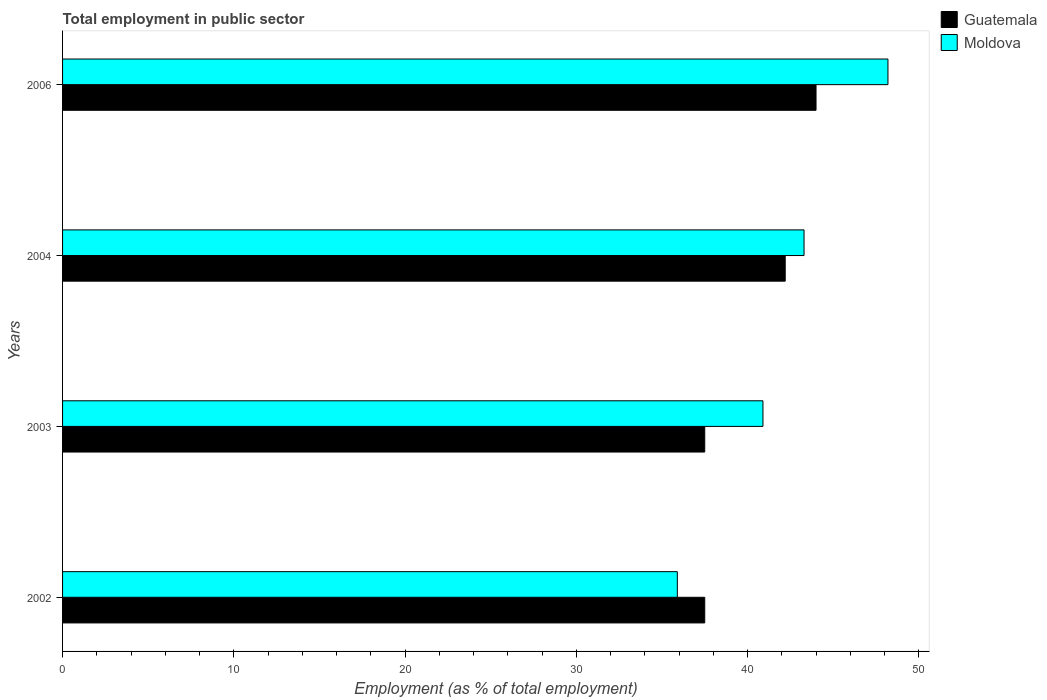How many different coloured bars are there?
Make the answer very short. 2. Are the number of bars per tick equal to the number of legend labels?
Your response must be concise. Yes. How many bars are there on the 4th tick from the top?
Offer a very short reply. 2. How many bars are there on the 4th tick from the bottom?
Your answer should be very brief. 2. What is the label of the 2nd group of bars from the top?
Offer a terse response. 2004. In how many cases, is the number of bars for a given year not equal to the number of legend labels?
Offer a very short reply. 0. What is the employment in public sector in Guatemala in 2002?
Provide a succinct answer. 37.5. Across all years, what is the maximum employment in public sector in Moldova?
Offer a terse response. 48.2. Across all years, what is the minimum employment in public sector in Moldova?
Give a very brief answer. 35.9. In which year was the employment in public sector in Guatemala maximum?
Ensure brevity in your answer.  2006. What is the total employment in public sector in Moldova in the graph?
Provide a short and direct response. 168.3. What is the difference between the employment in public sector in Moldova in 2004 and the employment in public sector in Guatemala in 2002?
Make the answer very short. 5.8. What is the average employment in public sector in Guatemala per year?
Keep it short and to the point. 40.3. In the year 2003, what is the difference between the employment in public sector in Moldova and employment in public sector in Guatemala?
Ensure brevity in your answer.  3.4. What is the ratio of the employment in public sector in Guatemala in 2003 to that in 2004?
Provide a short and direct response. 0.89. What is the difference between the highest and the second highest employment in public sector in Guatemala?
Offer a terse response. 1.8. What does the 2nd bar from the top in 2004 represents?
Offer a very short reply. Guatemala. What does the 1st bar from the bottom in 2004 represents?
Give a very brief answer. Guatemala. How many bars are there?
Make the answer very short. 8. How many years are there in the graph?
Offer a very short reply. 4. Are the values on the major ticks of X-axis written in scientific E-notation?
Keep it short and to the point. No. Does the graph contain grids?
Provide a succinct answer. No. Where does the legend appear in the graph?
Keep it short and to the point. Top right. How are the legend labels stacked?
Make the answer very short. Vertical. What is the title of the graph?
Ensure brevity in your answer.  Total employment in public sector. What is the label or title of the X-axis?
Keep it short and to the point. Employment (as % of total employment). What is the label or title of the Y-axis?
Offer a terse response. Years. What is the Employment (as % of total employment) of Guatemala in 2002?
Give a very brief answer. 37.5. What is the Employment (as % of total employment) of Moldova in 2002?
Keep it short and to the point. 35.9. What is the Employment (as % of total employment) in Guatemala in 2003?
Ensure brevity in your answer.  37.5. What is the Employment (as % of total employment) of Moldova in 2003?
Keep it short and to the point. 40.9. What is the Employment (as % of total employment) in Guatemala in 2004?
Your answer should be compact. 42.2. What is the Employment (as % of total employment) in Moldova in 2004?
Keep it short and to the point. 43.3. What is the Employment (as % of total employment) in Guatemala in 2006?
Provide a short and direct response. 44. What is the Employment (as % of total employment) in Moldova in 2006?
Your response must be concise. 48.2. Across all years, what is the maximum Employment (as % of total employment) in Guatemala?
Make the answer very short. 44. Across all years, what is the maximum Employment (as % of total employment) of Moldova?
Ensure brevity in your answer.  48.2. Across all years, what is the minimum Employment (as % of total employment) of Guatemala?
Make the answer very short. 37.5. Across all years, what is the minimum Employment (as % of total employment) of Moldova?
Provide a succinct answer. 35.9. What is the total Employment (as % of total employment) of Guatemala in the graph?
Your answer should be very brief. 161.2. What is the total Employment (as % of total employment) in Moldova in the graph?
Offer a terse response. 168.3. What is the difference between the Employment (as % of total employment) of Guatemala in 2002 and that in 2003?
Ensure brevity in your answer.  0. What is the difference between the Employment (as % of total employment) in Guatemala in 2002 and that in 2004?
Offer a very short reply. -4.7. What is the difference between the Employment (as % of total employment) in Moldova in 2002 and that in 2004?
Give a very brief answer. -7.4. What is the difference between the Employment (as % of total employment) in Guatemala in 2002 and that in 2006?
Your answer should be compact. -6.5. What is the difference between the Employment (as % of total employment) in Guatemala in 2003 and that in 2004?
Provide a succinct answer. -4.7. What is the difference between the Employment (as % of total employment) in Moldova in 2003 and that in 2006?
Provide a short and direct response. -7.3. What is the difference between the Employment (as % of total employment) in Guatemala in 2004 and that in 2006?
Give a very brief answer. -1.8. What is the difference between the Employment (as % of total employment) of Moldova in 2004 and that in 2006?
Make the answer very short. -4.9. What is the difference between the Employment (as % of total employment) in Guatemala in 2002 and the Employment (as % of total employment) in Moldova in 2003?
Offer a terse response. -3.4. What is the difference between the Employment (as % of total employment) in Guatemala in 2002 and the Employment (as % of total employment) in Moldova in 2004?
Ensure brevity in your answer.  -5.8. What is the difference between the Employment (as % of total employment) of Guatemala in 2002 and the Employment (as % of total employment) of Moldova in 2006?
Your response must be concise. -10.7. What is the average Employment (as % of total employment) of Guatemala per year?
Your response must be concise. 40.3. What is the average Employment (as % of total employment) of Moldova per year?
Your response must be concise. 42.08. In the year 2002, what is the difference between the Employment (as % of total employment) of Guatemala and Employment (as % of total employment) of Moldova?
Your answer should be compact. 1.6. What is the ratio of the Employment (as % of total employment) in Guatemala in 2002 to that in 2003?
Give a very brief answer. 1. What is the ratio of the Employment (as % of total employment) in Moldova in 2002 to that in 2003?
Your answer should be compact. 0.88. What is the ratio of the Employment (as % of total employment) in Guatemala in 2002 to that in 2004?
Make the answer very short. 0.89. What is the ratio of the Employment (as % of total employment) of Moldova in 2002 to that in 2004?
Offer a terse response. 0.83. What is the ratio of the Employment (as % of total employment) of Guatemala in 2002 to that in 2006?
Ensure brevity in your answer.  0.85. What is the ratio of the Employment (as % of total employment) of Moldova in 2002 to that in 2006?
Provide a succinct answer. 0.74. What is the ratio of the Employment (as % of total employment) in Guatemala in 2003 to that in 2004?
Your response must be concise. 0.89. What is the ratio of the Employment (as % of total employment) in Moldova in 2003 to that in 2004?
Your answer should be very brief. 0.94. What is the ratio of the Employment (as % of total employment) of Guatemala in 2003 to that in 2006?
Ensure brevity in your answer.  0.85. What is the ratio of the Employment (as % of total employment) in Moldova in 2003 to that in 2006?
Offer a very short reply. 0.85. What is the ratio of the Employment (as % of total employment) in Guatemala in 2004 to that in 2006?
Make the answer very short. 0.96. What is the ratio of the Employment (as % of total employment) in Moldova in 2004 to that in 2006?
Your answer should be very brief. 0.9. What is the difference between the highest and the second highest Employment (as % of total employment) of Guatemala?
Provide a succinct answer. 1.8. What is the difference between the highest and the lowest Employment (as % of total employment) in Guatemala?
Offer a terse response. 6.5. What is the difference between the highest and the lowest Employment (as % of total employment) of Moldova?
Give a very brief answer. 12.3. 